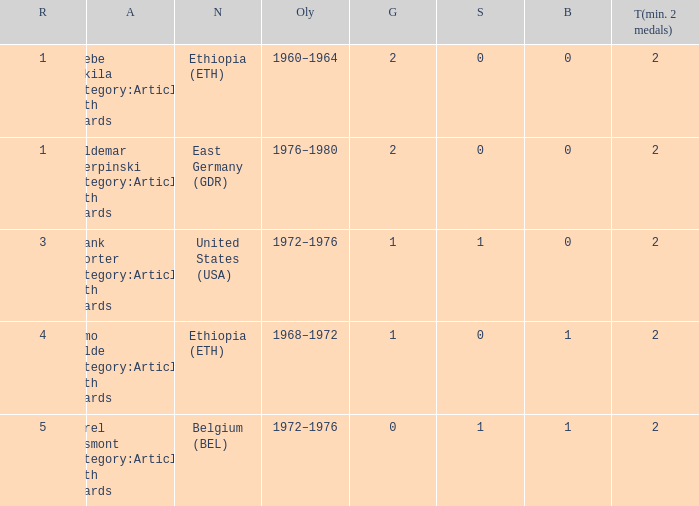Would you mind parsing the complete table? {'header': ['R', 'A', 'N', 'Oly', 'G', 'S', 'B', 'T(min. 2 medals)'], 'rows': [['1', 'Abebe Bikila Category:Articles with hCards', 'Ethiopia (ETH)', '1960–1964', '2', '0', '0', '2'], ['1', 'Waldemar Cierpinski Category:Articles with hCards', 'East Germany (GDR)', '1976–1980', '2', '0', '0', '2'], ['3', 'Frank Shorter Category:Articles with hCards', 'United States (USA)', '1972–1976', '1', '1', '0', '2'], ['4', 'Mamo Wolde Category:Articles with hCards', 'Ethiopia (ETH)', '1968–1972', '1', '0', '1', '2'], ['5', 'Karel Lismont Category:Articles with hCards', 'Belgium (BEL)', '1972–1976', '0', '1', '1', '2']]} What is the least amount of total medals won? 2.0. 